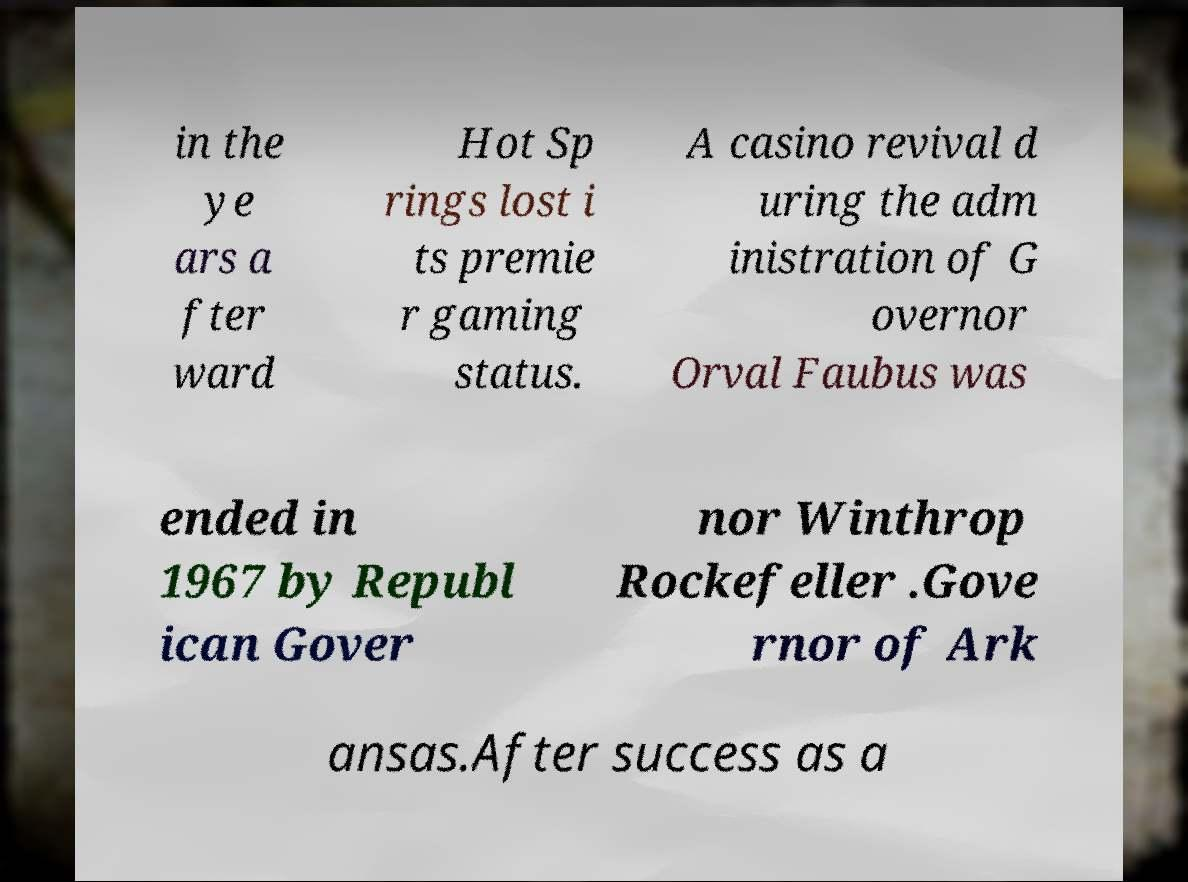Could you assist in decoding the text presented in this image and type it out clearly? in the ye ars a fter ward Hot Sp rings lost i ts premie r gaming status. A casino revival d uring the adm inistration of G overnor Orval Faubus was ended in 1967 by Republ ican Gover nor Winthrop Rockefeller .Gove rnor of Ark ansas.After success as a 